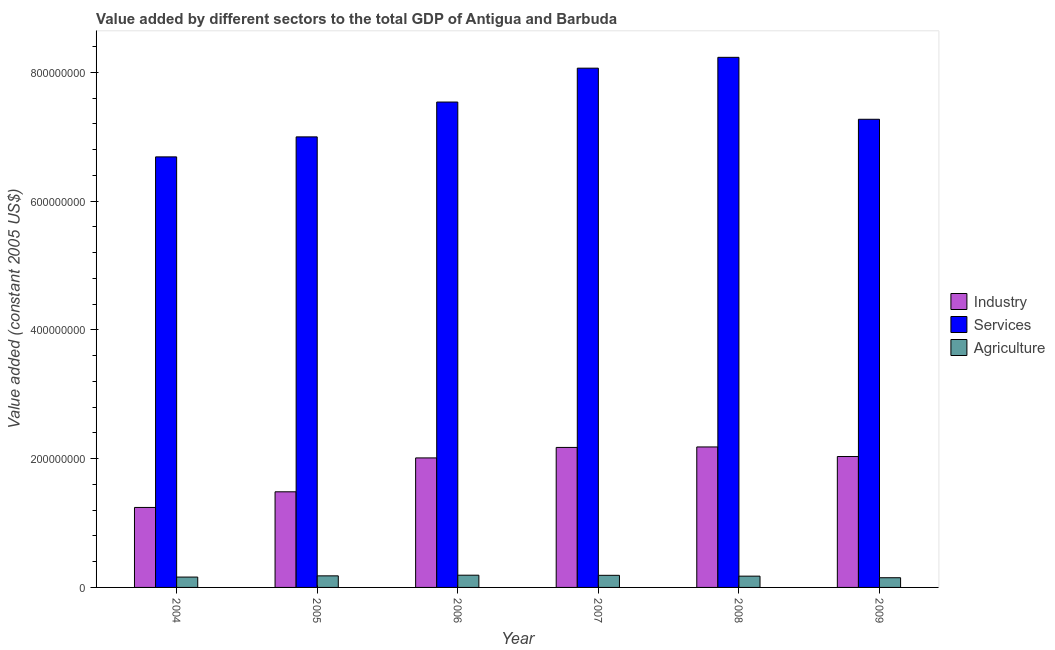How many different coloured bars are there?
Offer a terse response. 3. How many groups of bars are there?
Offer a very short reply. 6. Are the number of bars on each tick of the X-axis equal?
Provide a short and direct response. Yes. What is the value added by agricultural sector in 2006?
Provide a succinct answer. 1.90e+07. Across all years, what is the maximum value added by services?
Provide a succinct answer. 8.23e+08. Across all years, what is the minimum value added by services?
Provide a succinct answer. 6.69e+08. In which year was the value added by agricultural sector minimum?
Keep it short and to the point. 2009. What is the total value added by agricultural sector in the graph?
Your response must be concise. 1.04e+08. What is the difference between the value added by industrial sector in 2005 and that in 2009?
Your answer should be very brief. -5.48e+07. What is the difference between the value added by industrial sector in 2007 and the value added by services in 2005?
Your response must be concise. 6.89e+07. What is the average value added by agricultural sector per year?
Ensure brevity in your answer.  1.74e+07. In how many years, is the value added by services greater than 200000000 US$?
Provide a succinct answer. 6. What is the ratio of the value added by industrial sector in 2005 to that in 2006?
Your answer should be very brief. 0.74. Is the difference between the value added by agricultural sector in 2005 and 2006 greater than the difference between the value added by services in 2005 and 2006?
Ensure brevity in your answer.  No. What is the difference between the highest and the second highest value added by services?
Your response must be concise. 1.68e+07. What is the difference between the highest and the lowest value added by industrial sector?
Offer a terse response. 9.40e+07. Is the sum of the value added by services in 2005 and 2009 greater than the maximum value added by industrial sector across all years?
Your answer should be compact. Yes. What does the 1st bar from the left in 2008 represents?
Offer a very short reply. Industry. What does the 1st bar from the right in 2009 represents?
Give a very brief answer. Agriculture. Does the graph contain any zero values?
Your answer should be very brief. No. Does the graph contain grids?
Keep it short and to the point. No. Where does the legend appear in the graph?
Give a very brief answer. Center right. How are the legend labels stacked?
Keep it short and to the point. Vertical. What is the title of the graph?
Provide a short and direct response. Value added by different sectors to the total GDP of Antigua and Barbuda. Does "Ages 60+" appear as one of the legend labels in the graph?
Make the answer very short. No. What is the label or title of the Y-axis?
Ensure brevity in your answer.  Value added (constant 2005 US$). What is the Value added (constant 2005 US$) of Industry in 2004?
Your answer should be compact. 1.24e+08. What is the Value added (constant 2005 US$) in Services in 2004?
Keep it short and to the point. 6.69e+08. What is the Value added (constant 2005 US$) of Agriculture in 2004?
Offer a terse response. 1.61e+07. What is the Value added (constant 2005 US$) in Industry in 2005?
Give a very brief answer. 1.49e+08. What is the Value added (constant 2005 US$) in Services in 2005?
Your answer should be very brief. 7.00e+08. What is the Value added (constant 2005 US$) in Agriculture in 2005?
Offer a very short reply. 1.80e+07. What is the Value added (constant 2005 US$) in Industry in 2006?
Make the answer very short. 2.01e+08. What is the Value added (constant 2005 US$) of Services in 2006?
Offer a terse response. 7.54e+08. What is the Value added (constant 2005 US$) of Agriculture in 2006?
Your answer should be compact. 1.90e+07. What is the Value added (constant 2005 US$) in Industry in 2007?
Keep it short and to the point. 2.17e+08. What is the Value added (constant 2005 US$) of Services in 2007?
Your response must be concise. 8.07e+08. What is the Value added (constant 2005 US$) in Agriculture in 2007?
Provide a short and direct response. 1.88e+07. What is the Value added (constant 2005 US$) of Industry in 2008?
Ensure brevity in your answer.  2.18e+08. What is the Value added (constant 2005 US$) in Services in 2008?
Your response must be concise. 8.23e+08. What is the Value added (constant 2005 US$) in Agriculture in 2008?
Offer a very short reply. 1.75e+07. What is the Value added (constant 2005 US$) in Industry in 2009?
Give a very brief answer. 2.03e+08. What is the Value added (constant 2005 US$) in Services in 2009?
Keep it short and to the point. 7.27e+08. What is the Value added (constant 2005 US$) in Agriculture in 2009?
Keep it short and to the point. 1.51e+07. Across all years, what is the maximum Value added (constant 2005 US$) in Industry?
Provide a short and direct response. 2.18e+08. Across all years, what is the maximum Value added (constant 2005 US$) of Services?
Your answer should be very brief. 8.23e+08. Across all years, what is the maximum Value added (constant 2005 US$) of Agriculture?
Ensure brevity in your answer.  1.90e+07. Across all years, what is the minimum Value added (constant 2005 US$) in Industry?
Your answer should be very brief. 1.24e+08. Across all years, what is the minimum Value added (constant 2005 US$) in Services?
Provide a short and direct response. 6.69e+08. Across all years, what is the minimum Value added (constant 2005 US$) of Agriculture?
Your answer should be compact. 1.51e+07. What is the total Value added (constant 2005 US$) in Industry in the graph?
Your answer should be very brief. 1.11e+09. What is the total Value added (constant 2005 US$) of Services in the graph?
Ensure brevity in your answer.  4.48e+09. What is the total Value added (constant 2005 US$) in Agriculture in the graph?
Offer a very short reply. 1.04e+08. What is the difference between the Value added (constant 2005 US$) of Industry in 2004 and that in 2005?
Your answer should be very brief. -2.43e+07. What is the difference between the Value added (constant 2005 US$) in Services in 2004 and that in 2005?
Keep it short and to the point. -3.11e+07. What is the difference between the Value added (constant 2005 US$) in Agriculture in 2004 and that in 2005?
Your answer should be very brief. -1.89e+06. What is the difference between the Value added (constant 2005 US$) in Industry in 2004 and that in 2006?
Provide a short and direct response. -7.69e+07. What is the difference between the Value added (constant 2005 US$) in Services in 2004 and that in 2006?
Make the answer very short. -8.52e+07. What is the difference between the Value added (constant 2005 US$) of Agriculture in 2004 and that in 2006?
Offer a very short reply. -2.91e+06. What is the difference between the Value added (constant 2005 US$) in Industry in 2004 and that in 2007?
Offer a very short reply. -9.32e+07. What is the difference between the Value added (constant 2005 US$) in Services in 2004 and that in 2007?
Your answer should be compact. -1.38e+08. What is the difference between the Value added (constant 2005 US$) in Agriculture in 2004 and that in 2007?
Keep it short and to the point. -2.73e+06. What is the difference between the Value added (constant 2005 US$) of Industry in 2004 and that in 2008?
Ensure brevity in your answer.  -9.40e+07. What is the difference between the Value added (constant 2005 US$) of Services in 2004 and that in 2008?
Your answer should be very brief. -1.55e+08. What is the difference between the Value added (constant 2005 US$) of Agriculture in 2004 and that in 2008?
Offer a terse response. -1.44e+06. What is the difference between the Value added (constant 2005 US$) of Industry in 2004 and that in 2009?
Give a very brief answer. -7.91e+07. What is the difference between the Value added (constant 2005 US$) of Services in 2004 and that in 2009?
Your answer should be compact. -5.84e+07. What is the difference between the Value added (constant 2005 US$) in Agriculture in 2004 and that in 2009?
Your response must be concise. 1.02e+06. What is the difference between the Value added (constant 2005 US$) of Industry in 2005 and that in 2006?
Give a very brief answer. -5.26e+07. What is the difference between the Value added (constant 2005 US$) in Services in 2005 and that in 2006?
Offer a very short reply. -5.41e+07. What is the difference between the Value added (constant 2005 US$) in Agriculture in 2005 and that in 2006?
Provide a short and direct response. -1.02e+06. What is the difference between the Value added (constant 2005 US$) in Industry in 2005 and that in 2007?
Offer a very short reply. -6.89e+07. What is the difference between the Value added (constant 2005 US$) of Services in 2005 and that in 2007?
Offer a terse response. -1.07e+08. What is the difference between the Value added (constant 2005 US$) of Agriculture in 2005 and that in 2007?
Your answer should be very brief. -8.46e+05. What is the difference between the Value added (constant 2005 US$) of Industry in 2005 and that in 2008?
Keep it short and to the point. -6.97e+07. What is the difference between the Value added (constant 2005 US$) in Services in 2005 and that in 2008?
Your response must be concise. -1.24e+08. What is the difference between the Value added (constant 2005 US$) in Agriculture in 2005 and that in 2008?
Keep it short and to the point. 4.46e+05. What is the difference between the Value added (constant 2005 US$) of Industry in 2005 and that in 2009?
Provide a short and direct response. -5.48e+07. What is the difference between the Value added (constant 2005 US$) of Services in 2005 and that in 2009?
Give a very brief answer. -2.74e+07. What is the difference between the Value added (constant 2005 US$) in Agriculture in 2005 and that in 2009?
Offer a terse response. 2.91e+06. What is the difference between the Value added (constant 2005 US$) of Industry in 2006 and that in 2007?
Provide a succinct answer. -1.63e+07. What is the difference between the Value added (constant 2005 US$) of Services in 2006 and that in 2007?
Make the answer very short. -5.26e+07. What is the difference between the Value added (constant 2005 US$) in Agriculture in 2006 and that in 2007?
Ensure brevity in your answer.  1.78e+05. What is the difference between the Value added (constant 2005 US$) of Industry in 2006 and that in 2008?
Your response must be concise. -1.71e+07. What is the difference between the Value added (constant 2005 US$) of Services in 2006 and that in 2008?
Offer a terse response. -6.95e+07. What is the difference between the Value added (constant 2005 US$) of Agriculture in 2006 and that in 2008?
Your response must be concise. 1.47e+06. What is the difference between the Value added (constant 2005 US$) of Industry in 2006 and that in 2009?
Make the answer very short. -2.17e+06. What is the difference between the Value added (constant 2005 US$) in Services in 2006 and that in 2009?
Your answer should be very brief. 2.68e+07. What is the difference between the Value added (constant 2005 US$) in Agriculture in 2006 and that in 2009?
Your answer should be very brief. 3.93e+06. What is the difference between the Value added (constant 2005 US$) of Industry in 2007 and that in 2008?
Ensure brevity in your answer.  -7.64e+05. What is the difference between the Value added (constant 2005 US$) of Services in 2007 and that in 2008?
Offer a very short reply. -1.68e+07. What is the difference between the Value added (constant 2005 US$) of Agriculture in 2007 and that in 2008?
Keep it short and to the point. 1.29e+06. What is the difference between the Value added (constant 2005 US$) in Industry in 2007 and that in 2009?
Give a very brief answer. 1.41e+07. What is the difference between the Value added (constant 2005 US$) of Services in 2007 and that in 2009?
Your answer should be very brief. 7.94e+07. What is the difference between the Value added (constant 2005 US$) in Agriculture in 2007 and that in 2009?
Offer a very short reply. 3.76e+06. What is the difference between the Value added (constant 2005 US$) of Industry in 2008 and that in 2009?
Keep it short and to the point. 1.49e+07. What is the difference between the Value added (constant 2005 US$) of Services in 2008 and that in 2009?
Make the answer very short. 9.62e+07. What is the difference between the Value added (constant 2005 US$) of Agriculture in 2008 and that in 2009?
Offer a terse response. 2.46e+06. What is the difference between the Value added (constant 2005 US$) of Industry in 2004 and the Value added (constant 2005 US$) of Services in 2005?
Make the answer very short. -5.76e+08. What is the difference between the Value added (constant 2005 US$) of Industry in 2004 and the Value added (constant 2005 US$) of Agriculture in 2005?
Provide a short and direct response. 1.06e+08. What is the difference between the Value added (constant 2005 US$) of Services in 2004 and the Value added (constant 2005 US$) of Agriculture in 2005?
Your response must be concise. 6.51e+08. What is the difference between the Value added (constant 2005 US$) of Industry in 2004 and the Value added (constant 2005 US$) of Services in 2006?
Offer a very short reply. -6.30e+08. What is the difference between the Value added (constant 2005 US$) of Industry in 2004 and the Value added (constant 2005 US$) of Agriculture in 2006?
Ensure brevity in your answer.  1.05e+08. What is the difference between the Value added (constant 2005 US$) of Services in 2004 and the Value added (constant 2005 US$) of Agriculture in 2006?
Your answer should be compact. 6.50e+08. What is the difference between the Value added (constant 2005 US$) of Industry in 2004 and the Value added (constant 2005 US$) of Services in 2007?
Your answer should be very brief. -6.82e+08. What is the difference between the Value added (constant 2005 US$) in Industry in 2004 and the Value added (constant 2005 US$) in Agriculture in 2007?
Your answer should be very brief. 1.05e+08. What is the difference between the Value added (constant 2005 US$) in Services in 2004 and the Value added (constant 2005 US$) in Agriculture in 2007?
Give a very brief answer. 6.50e+08. What is the difference between the Value added (constant 2005 US$) in Industry in 2004 and the Value added (constant 2005 US$) in Services in 2008?
Make the answer very short. -6.99e+08. What is the difference between the Value added (constant 2005 US$) of Industry in 2004 and the Value added (constant 2005 US$) of Agriculture in 2008?
Give a very brief answer. 1.07e+08. What is the difference between the Value added (constant 2005 US$) of Services in 2004 and the Value added (constant 2005 US$) of Agriculture in 2008?
Your answer should be very brief. 6.51e+08. What is the difference between the Value added (constant 2005 US$) of Industry in 2004 and the Value added (constant 2005 US$) of Services in 2009?
Make the answer very short. -6.03e+08. What is the difference between the Value added (constant 2005 US$) of Industry in 2004 and the Value added (constant 2005 US$) of Agriculture in 2009?
Keep it short and to the point. 1.09e+08. What is the difference between the Value added (constant 2005 US$) in Services in 2004 and the Value added (constant 2005 US$) in Agriculture in 2009?
Ensure brevity in your answer.  6.54e+08. What is the difference between the Value added (constant 2005 US$) in Industry in 2005 and the Value added (constant 2005 US$) in Services in 2006?
Offer a terse response. -6.05e+08. What is the difference between the Value added (constant 2005 US$) in Industry in 2005 and the Value added (constant 2005 US$) in Agriculture in 2006?
Provide a short and direct response. 1.30e+08. What is the difference between the Value added (constant 2005 US$) in Services in 2005 and the Value added (constant 2005 US$) in Agriculture in 2006?
Your answer should be compact. 6.81e+08. What is the difference between the Value added (constant 2005 US$) of Industry in 2005 and the Value added (constant 2005 US$) of Services in 2007?
Your response must be concise. -6.58e+08. What is the difference between the Value added (constant 2005 US$) in Industry in 2005 and the Value added (constant 2005 US$) in Agriculture in 2007?
Your answer should be compact. 1.30e+08. What is the difference between the Value added (constant 2005 US$) of Services in 2005 and the Value added (constant 2005 US$) of Agriculture in 2007?
Your answer should be very brief. 6.81e+08. What is the difference between the Value added (constant 2005 US$) of Industry in 2005 and the Value added (constant 2005 US$) of Services in 2008?
Offer a very short reply. -6.75e+08. What is the difference between the Value added (constant 2005 US$) of Industry in 2005 and the Value added (constant 2005 US$) of Agriculture in 2008?
Keep it short and to the point. 1.31e+08. What is the difference between the Value added (constant 2005 US$) in Services in 2005 and the Value added (constant 2005 US$) in Agriculture in 2008?
Offer a terse response. 6.82e+08. What is the difference between the Value added (constant 2005 US$) of Industry in 2005 and the Value added (constant 2005 US$) of Services in 2009?
Your answer should be very brief. -5.79e+08. What is the difference between the Value added (constant 2005 US$) in Industry in 2005 and the Value added (constant 2005 US$) in Agriculture in 2009?
Provide a short and direct response. 1.33e+08. What is the difference between the Value added (constant 2005 US$) of Services in 2005 and the Value added (constant 2005 US$) of Agriculture in 2009?
Your response must be concise. 6.85e+08. What is the difference between the Value added (constant 2005 US$) of Industry in 2006 and the Value added (constant 2005 US$) of Services in 2007?
Give a very brief answer. -6.05e+08. What is the difference between the Value added (constant 2005 US$) in Industry in 2006 and the Value added (constant 2005 US$) in Agriculture in 2007?
Your answer should be compact. 1.82e+08. What is the difference between the Value added (constant 2005 US$) in Services in 2006 and the Value added (constant 2005 US$) in Agriculture in 2007?
Provide a succinct answer. 7.35e+08. What is the difference between the Value added (constant 2005 US$) in Industry in 2006 and the Value added (constant 2005 US$) in Services in 2008?
Your answer should be compact. -6.22e+08. What is the difference between the Value added (constant 2005 US$) of Industry in 2006 and the Value added (constant 2005 US$) of Agriculture in 2008?
Make the answer very short. 1.84e+08. What is the difference between the Value added (constant 2005 US$) of Services in 2006 and the Value added (constant 2005 US$) of Agriculture in 2008?
Your response must be concise. 7.36e+08. What is the difference between the Value added (constant 2005 US$) in Industry in 2006 and the Value added (constant 2005 US$) in Services in 2009?
Make the answer very short. -5.26e+08. What is the difference between the Value added (constant 2005 US$) in Industry in 2006 and the Value added (constant 2005 US$) in Agriculture in 2009?
Your answer should be very brief. 1.86e+08. What is the difference between the Value added (constant 2005 US$) of Services in 2006 and the Value added (constant 2005 US$) of Agriculture in 2009?
Offer a terse response. 7.39e+08. What is the difference between the Value added (constant 2005 US$) of Industry in 2007 and the Value added (constant 2005 US$) of Services in 2008?
Provide a short and direct response. -6.06e+08. What is the difference between the Value added (constant 2005 US$) in Industry in 2007 and the Value added (constant 2005 US$) in Agriculture in 2008?
Offer a terse response. 2.00e+08. What is the difference between the Value added (constant 2005 US$) in Services in 2007 and the Value added (constant 2005 US$) in Agriculture in 2008?
Keep it short and to the point. 7.89e+08. What is the difference between the Value added (constant 2005 US$) of Industry in 2007 and the Value added (constant 2005 US$) of Services in 2009?
Your answer should be compact. -5.10e+08. What is the difference between the Value added (constant 2005 US$) in Industry in 2007 and the Value added (constant 2005 US$) in Agriculture in 2009?
Keep it short and to the point. 2.02e+08. What is the difference between the Value added (constant 2005 US$) in Services in 2007 and the Value added (constant 2005 US$) in Agriculture in 2009?
Offer a terse response. 7.92e+08. What is the difference between the Value added (constant 2005 US$) of Industry in 2008 and the Value added (constant 2005 US$) of Services in 2009?
Make the answer very short. -5.09e+08. What is the difference between the Value added (constant 2005 US$) in Industry in 2008 and the Value added (constant 2005 US$) in Agriculture in 2009?
Give a very brief answer. 2.03e+08. What is the difference between the Value added (constant 2005 US$) of Services in 2008 and the Value added (constant 2005 US$) of Agriculture in 2009?
Ensure brevity in your answer.  8.08e+08. What is the average Value added (constant 2005 US$) of Industry per year?
Offer a terse response. 1.85e+08. What is the average Value added (constant 2005 US$) in Services per year?
Offer a terse response. 7.47e+08. What is the average Value added (constant 2005 US$) in Agriculture per year?
Provide a short and direct response. 1.74e+07. In the year 2004, what is the difference between the Value added (constant 2005 US$) in Industry and Value added (constant 2005 US$) in Services?
Provide a short and direct response. -5.45e+08. In the year 2004, what is the difference between the Value added (constant 2005 US$) of Industry and Value added (constant 2005 US$) of Agriculture?
Provide a short and direct response. 1.08e+08. In the year 2004, what is the difference between the Value added (constant 2005 US$) in Services and Value added (constant 2005 US$) in Agriculture?
Make the answer very short. 6.53e+08. In the year 2005, what is the difference between the Value added (constant 2005 US$) in Industry and Value added (constant 2005 US$) in Services?
Give a very brief answer. -5.51e+08. In the year 2005, what is the difference between the Value added (constant 2005 US$) of Industry and Value added (constant 2005 US$) of Agriculture?
Your response must be concise. 1.31e+08. In the year 2005, what is the difference between the Value added (constant 2005 US$) in Services and Value added (constant 2005 US$) in Agriculture?
Your response must be concise. 6.82e+08. In the year 2006, what is the difference between the Value added (constant 2005 US$) in Industry and Value added (constant 2005 US$) in Services?
Your answer should be very brief. -5.53e+08. In the year 2006, what is the difference between the Value added (constant 2005 US$) of Industry and Value added (constant 2005 US$) of Agriculture?
Your answer should be compact. 1.82e+08. In the year 2006, what is the difference between the Value added (constant 2005 US$) of Services and Value added (constant 2005 US$) of Agriculture?
Keep it short and to the point. 7.35e+08. In the year 2007, what is the difference between the Value added (constant 2005 US$) in Industry and Value added (constant 2005 US$) in Services?
Give a very brief answer. -5.89e+08. In the year 2007, what is the difference between the Value added (constant 2005 US$) of Industry and Value added (constant 2005 US$) of Agriculture?
Offer a terse response. 1.99e+08. In the year 2007, what is the difference between the Value added (constant 2005 US$) of Services and Value added (constant 2005 US$) of Agriculture?
Provide a short and direct response. 7.88e+08. In the year 2008, what is the difference between the Value added (constant 2005 US$) in Industry and Value added (constant 2005 US$) in Services?
Provide a succinct answer. -6.05e+08. In the year 2008, what is the difference between the Value added (constant 2005 US$) of Industry and Value added (constant 2005 US$) of Agriculture?
Provide a succinct answer. 2.01e+08. In the year 2008, what is the difference between the Value added (constant 2005 US$) of Services and Value added (constant 2005 US$) of Agriculture?
Ensure brevity in your answer.  8.06e+08. In the year 2009, what is the difference between the Value added (constant 2005 US$) of Industry and Value added (constant 2005 US$) of Services?
Provide a succinct answer. -5.24e+08. In the year 2009, what is the difference between the Value added (constant 2005 US$) of Industry and Value added (constant 2005 US$) of Agriculture?
Offer a terse response. 1.88e+08. In the year 2009, what is the difference between the Value added (constant 2005 US$) of Services and Value added (constant 2005 US$) of Agriculture?
Give a very brief answer. 7.12e+08. What is the ratio of the Value added (constant 2005 US$) in Industry in 2004 to that in 2005?
Give a very brief answer. 0.84. What is the ratio of the Value added (constant 2005 US$) in Services in 2004 to that in 2005?
Give a very brief answer. 0.96. What is the ratio of the Value added (constant 2005 US$) of Agriculture in 2004 to that in 2005?
Make the answer very short. 0.9. What is the ratio of the Value added (constant 2005 US$) of Industry in 2004 to that in 2006?
Your response must be concise. 0.62. What is the ratio of the Value added (constant 2005 US$) in Services in 2004 to that in 2006?
Keep it short and to the point. 0.89. What is the ratio of the Value added (constant 2005 US$) in Agriculture in 2004 to that in 2006?
Provide a succinct answer. 0.85. What is the ratio of the Value added (constant 2005 US$) of Industry in 2004 to that in 2007?
Offer a terse response. 0.57. What is the ratio of the Value added (constant 2005 US$) of Services in 2004 to that in 2007?
Your response must be concise. 0.83. What is the ratio of the Value added (constant 2005 US$) of Agriculture in 2004 to that in 2007?
Your answer should be very brief. 0.85. What is the ratio of the Value added (constant 2005 US$) of Industry in 2004 to that in 2008?
Give a very brief answer. 0.57. What is the ratio of the Value added (constant 2005 US$) in Services in 2004 to that in 2008?
Your answer should be very brief. 0.81. What is the ratio of the Value added (constant 2005 US$) of Agriculture in 2004 to that in 2008?
Your response must be concise. 0.92. What is the ratio of the Value added (constant 2005 US$) in Industry in 2004 to that in 2009?
Your answer should be very brief. 0.61. What is the ratio of the Value added (constant 2005 US$) of Services in 2004 to that in 2009?
Make the answer very short. 0.92. What is the ratio of the Value added (constant 2005 US$) of Agriculture in 2004 to that in 2009?
Give a very brief answer. 1.07. What is the ratio of the Value added (constant 2005 US$) in Industry in 2005 to that in 2006?
Give a very brief answer. 0.74. What is the ratio of the Value added (constant 2005 US$) of Services in 2005 to that in 2006?
Give a very brief answer. 0.93. What is the ratio of the Value added (constant 2005 US$) in Agriculture in 2005 to that in 2006?
Provide a short and direct response. 0.95. What is the ratio of the Value added (constant 2005 US$) in Industry in 2005 to that in 2007?
Your answer should be compact. 0.68. What is the ratio of the Value added (constant 2005 US$) in Services in 2005 to that in 2007?
Keep it short and to the point. 0.87. What is the ratio of the Value added (constant 2005 US$) of Agriculture in 2005 to that in 2007?
Your answer should be compact. 0.95. What is the ratio of the Value added (constant 2005 US$) in Industry in 2005 to that in 2008?
Your answer should be compact. 0.68. What is the ratio of the Value added (constant 2005 US$) in Services in 2005 to that in 2008?
Offer a very short reply. 0.85. What is the ratio of the Value added (constant 2005 US$) of Agriculture in 2005 to that in 2008?
Offer a very short reply. 1.03. What is the ratio of the Value added (constant 2005 US$) in Industry in 2005 to that in 2009?
Offer a very short reply. 0.73. What is the ratio of the Value added (constant 2005 US$) of Services in 2005 to that in 2009?
Your answer should be very brief. 0.96. What is the ratio of the Value added (constant 2005 US$) of Agriculture in 2005 to that in 2009?
Ensure brevity in your answer.  1.19. What is the ratio of the Value added (constant 2005 US$) of Industry in 2006 to that in 2007?
Make the answer very short. 0.93. What is the ratio of the Value added (constant 2005 US$) of Services in 2006 to that in 2007?
Give a very brief answer. 0.93. What is the ratio of the Value added (constant 2005 US$) in Agriculture in 2006 to that in 2007?
Provide a short and direct response. 1.01. What is the ratio of the Value added (constant 2005 US$) of Industry in 2006 to that in 2008?
Offer a terse response. 0.92. What is the ratio of the Value added (constant 2005 US$) of Services in 2006 to that in 2008?
Offer a terse response. 0.92. What is the ratio of the Value added (constant 2005 US$) of Agriculture in 2006 to that in 2008?
Give a very brief answer. 1.08. What is the ratio of the Value added (constant 2005 US$) of Industry in 2006 to that in 2009?
Your response must be concise. 0.99. What is the ratio of the Value added (constant 2005 US$) in Services in 2006 to that in 2009?
Your answer should be compact. 1.04. What is the ratio of the Value added (constant 2005 US$) of Agriculture in 2006 to that in 2009?
Keep it short and to the point. 1.26. What is the ratio of the Value added (constant 2005 US$) of Services in 2007 to that in 2008?
Give a very brief answer. 0.98. What is the ratio of the Value added (constant 2005 US$) of Agriculture in 2007 to that in 2008?
Keep it short and to the point. 1.07. What is the ratio of the Value added (constant 2005 US$) in Industry in 2007 to that in 2009?
Your answer should be compact. 1.07. What is the ratio of the Value added (constant 2005 US$) of Services in 2007 to that in 2009?
Make the answer very short. 1.11. What is the ratio of the Value added (constant 2005 US$) in Agriculture in 2007 to that in 2009?
Ensure brevity in your answer.  1.25. What is the ratio of the Value added (constant 2005 US$) in Industry in 2008 to that in 2009?
Offer a very short reply. 1.07. What is the ratio of the Value added (constant 2005 US$) in Services in 2008 to that in 2009?
Offer a terse response. 1.13. What is the ratio of the Value added (constant 2005 US$) in Agriculture in 2008 to that in 2009?
Ensure brevity in your answer.  1.16. What is the difference between the highest and the second highest Value added (constant 2005 US$) in Industry?
Offer a very short reply. 7.64e+05. What is the difference between the highest and the second highest Value added (constant 2005 US$) of Services?
Ensure brevity in your answer.  1.68e+07. What is the difference between the highest and the second highest Value added (constant 2005 US$) in Agriculture?
Ensure brevity in your answer.  1.78e+05. What is the difference between the highest and the lowest Value added (constant 2005 US$) of Industry?
Your answer should be very brief. 9.40e+07. What is the difference between the highest and the lowest Value added (constant 2005 US$) in Services?
Give a very brief answer. 1.55e+08. What is the difference between the highest and the lowest Value added (constant 2005 US$) of Agriculture?
Your answer should be very brief. 3.93e+06. 